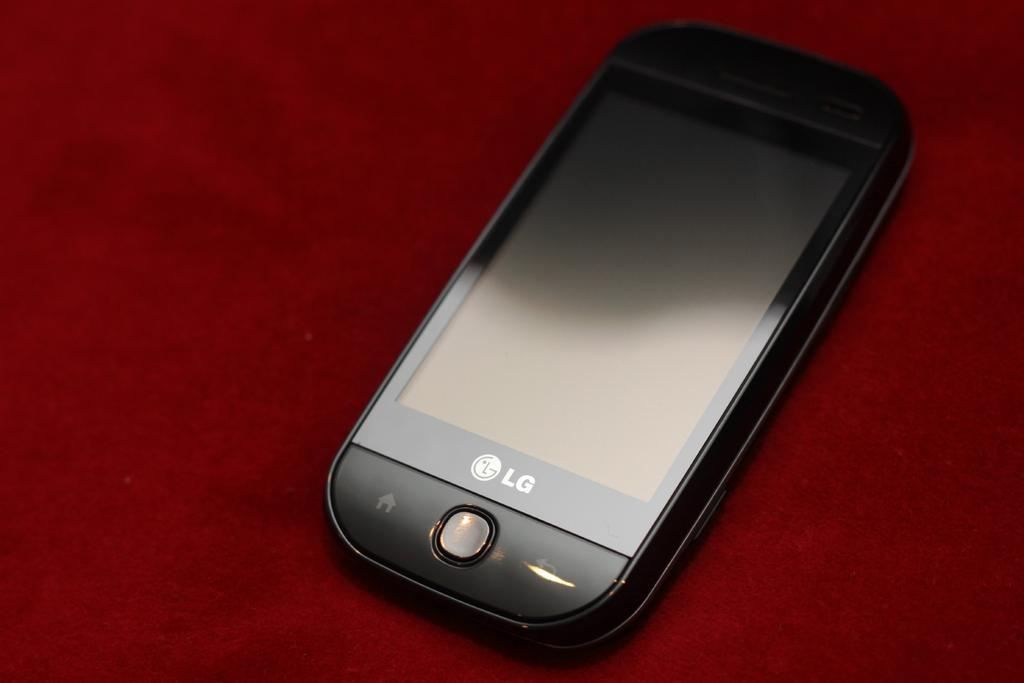Provide a one-sentence caption for the provided image. An LG brand cell phone is on top of a red background. 